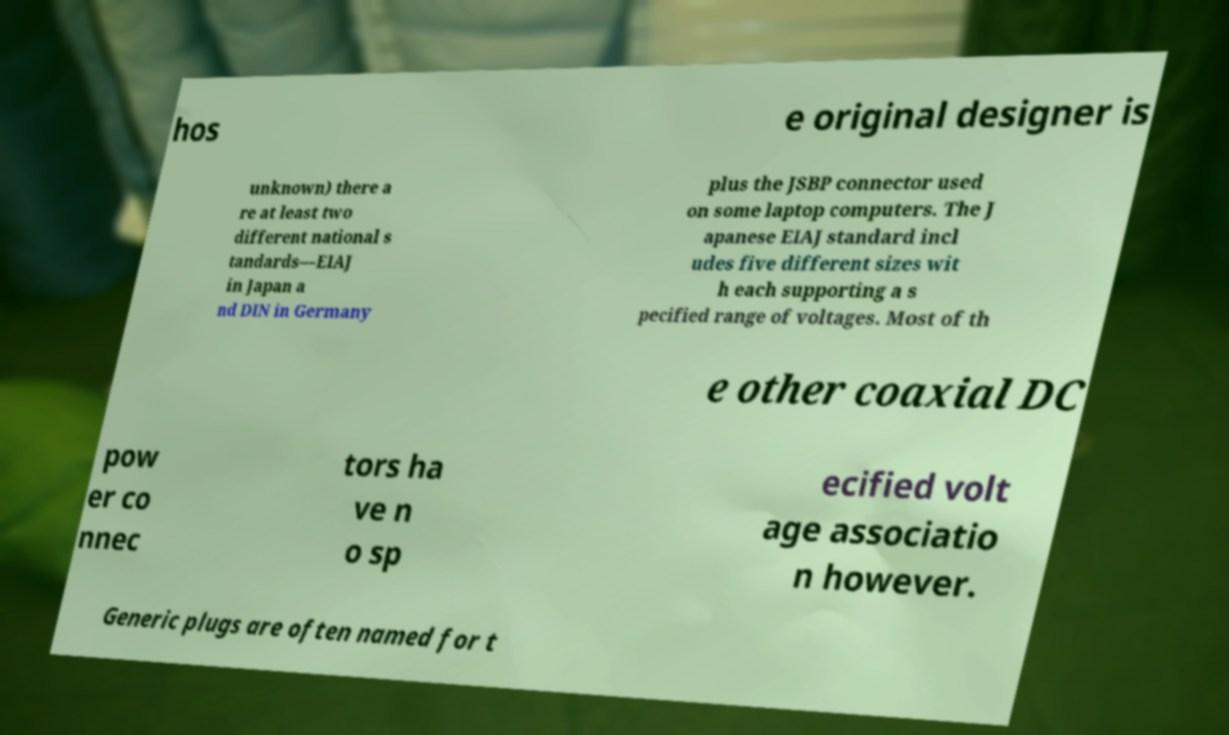Could you extract and type out the text from this image? hos e original designer is unknown) there a re at least two different national s tandards—EIAJ in Japan a nd DIN in Germany plus the JSBP connector used on some laptop computers. The J apanese EIAJ standard incl udes five different sizes wit h each supporting a s pecified range of voltages. Most of th e other coaxial DC pow er co nnec tors ha ve n o sp ecified volt age associatio n however. Generic plugs are often named for t 